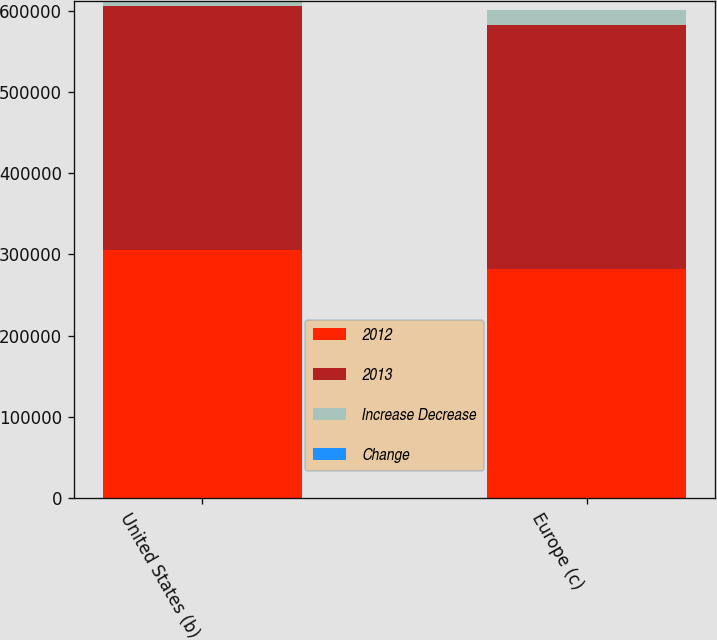<chart> <loc_0><loc_0><loc_500><loc_500><stacked_bar_chart><ecel><fcel>United States (b)<fcel>Europe (c)<nl><fcel>2012<fcel>305852<fcel>281844<nl><fcel>2013<fcel>299384<fcel>300415<nl><fcel>Increase Decrease<fcel>6468<fcel>18571<nl><fcel>Change<fcel>2.2<fcel>6.2<nl></chart> 